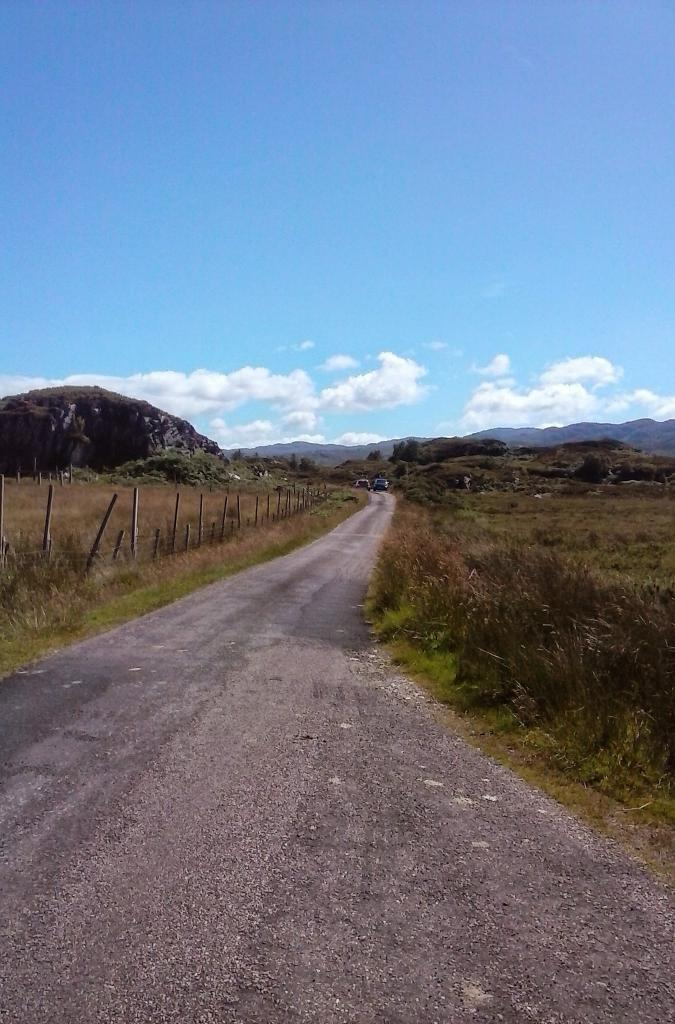What can be seen on the road in the image? There are vehicles on the road in the image. What type of vegetation is visible in the image? There is grass visible in the image. What is separating the grass from the road in the image? There is a fence in the image. What geographical feature can be seen in the background of the image? There is a mountain in the image. What is visible in the sky in the image? The sky is visible in the background of the image, and there are clouds in the sky. What type of apparel is the mountain wearing in the image? The mountain is not wearing any apparel, as it is a geographical feature and not a living being. Can you describe the body language of the clouds in the image? The clouds do not have body language, as they are a natural phenomenon and not living beings. 